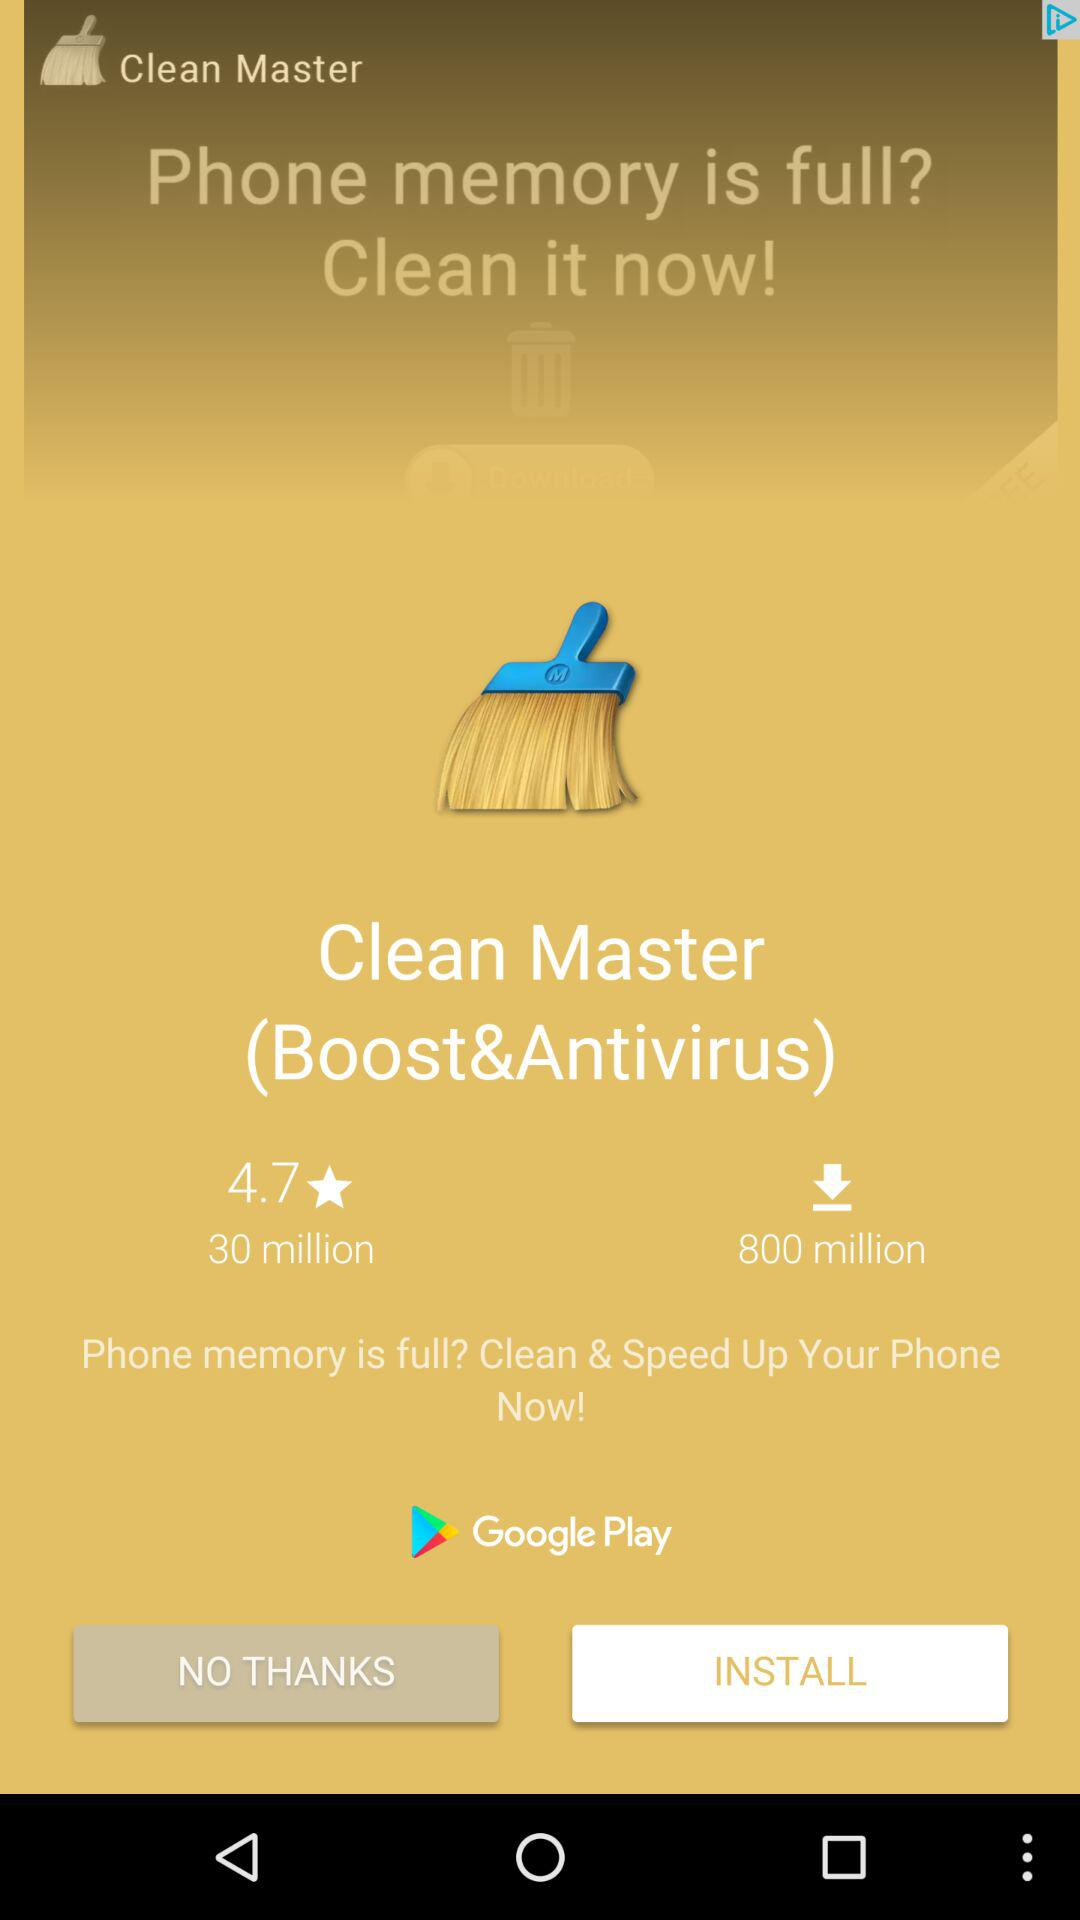How many more downloads does Clean Master have than 30 million?
Answer the question using a single word or phrase. 770 million 